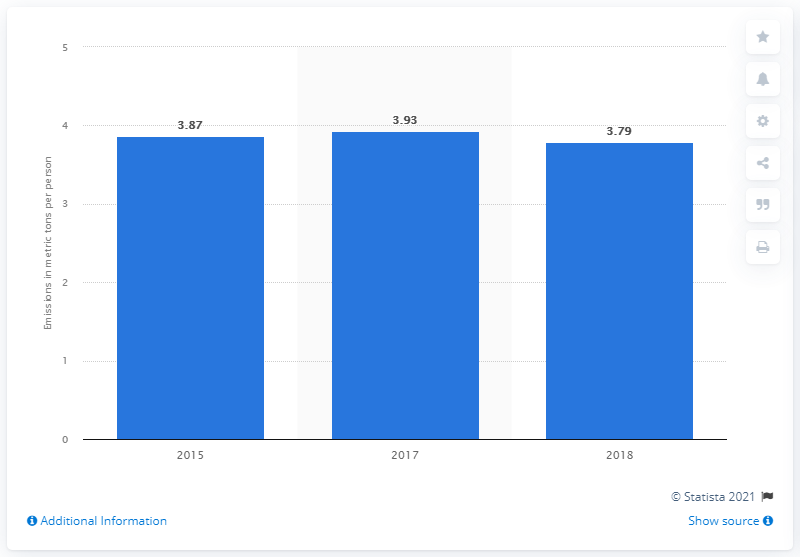Point out several critical features in this image. In 2017, the amount of fossil CO emissions per person in Mexico was 3.93. In 2017, Mexico's fossil CO emissions reached 3.79 metric tons per person. 